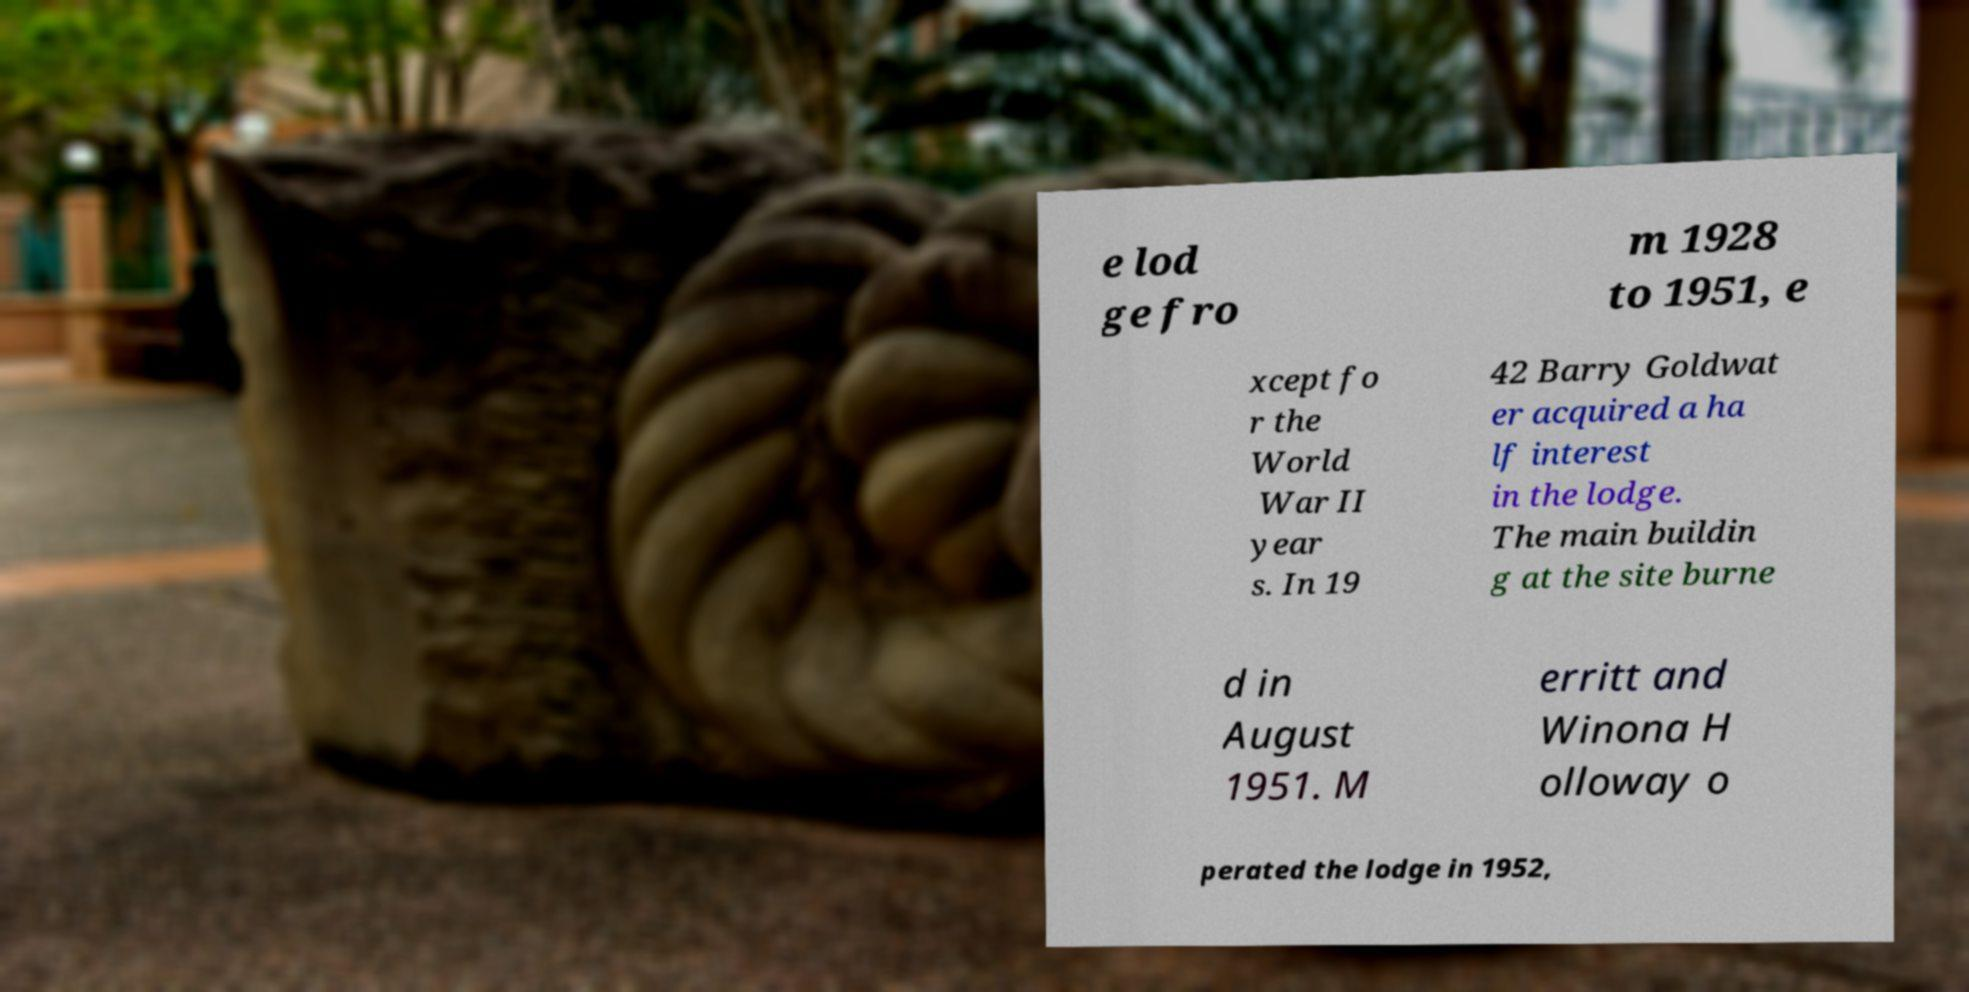Can you accurately transcribe the text from the provided image for me? e lod ge fro m 1928 to 1951, e xcept fo r the World War II year s. In 19 42 Barry Goldwat er acquired a ha lf interest in the lodge. The main buildin g at the site burne d in August 1951. M erritt and Winona H olloway o perated the lodge in 1952, 